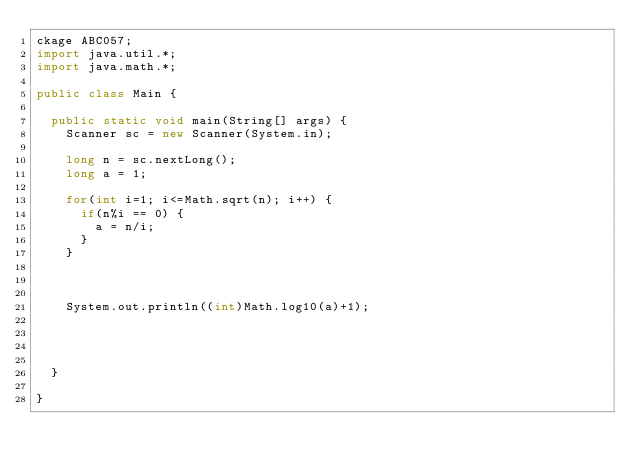<code> <loc_0><loc_0><loc_500><loc_500><_Java_>ckage ABC057;
import java.util.*;
import java.math.*;

public class Main {

	public static void main(String[] args) {
		Scanner sc = new Scanner(System.in);
		
		long n = sc.nextLong();
		long a = 1;	
		
		for(int i=1; i<=Math.sqrt(n); i++) {
			if(n%i == 0) {
				a = n/i;
			}
		}
		
		
		
		System.out.println((int)Math.log10(a)+1);
		
		
		

	}

}
</code> 